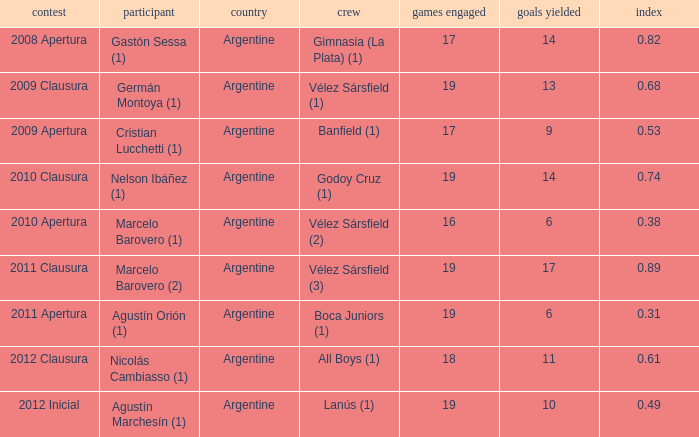What is the coefficient for agustín marchesín (1)? 0.49. Could you help me parse every detail presented in this table? {'header': ['contest', 'participant', 'country', 'crew', 'games engaged', 'goals yielded', 'index'], 'rows': [['2008 Apertura', 'Gastón Sessa (1)', 'Argentine', 'Gimnasia (La Plata) (1)', '17', '14', '0.82'], ['2009 Clausura', 'Germán Montoya (1)', 'Argentine', 'Vélez Sársfield (1)', '19', '13', '0.68'], ['2009 Apertura', 'Cristian Lucchetti (1)', 'Argentine', 'Banfield (1)', '17', '9', '0.53'], ['2010 Clausura', 'Nelson Ibáñez (1)', 'Argentine', 'Godoy Cruz (1)', '19', '14', '0.74'], ['2010 Apertura', 'Marcelo Barovero (1)', 'Argentine', 'Vélez Sársfield (2)', '16', '6', '0.38'], ['2011 Clausura', 'Marcelo Barovero (2)', 'Argentine', 'Vélez Sársfield (3)', '19', '17', '0.89'], ['2011 Apertura', 'Agustín Orión (1)', 'Argentine', 'Boca Juniors (1)', '19', '6', '0.31'], ['2012 Clausura', 'Nicolás Cambiasso (1)', 'Argentine', 'All Boys (1)', '18', '11', '0.61'], ['2012 Inicial', 'Agustín Marchesín (1)', 'Argentine', 'Lanús (1)', '19', '10', '0.49']]} 